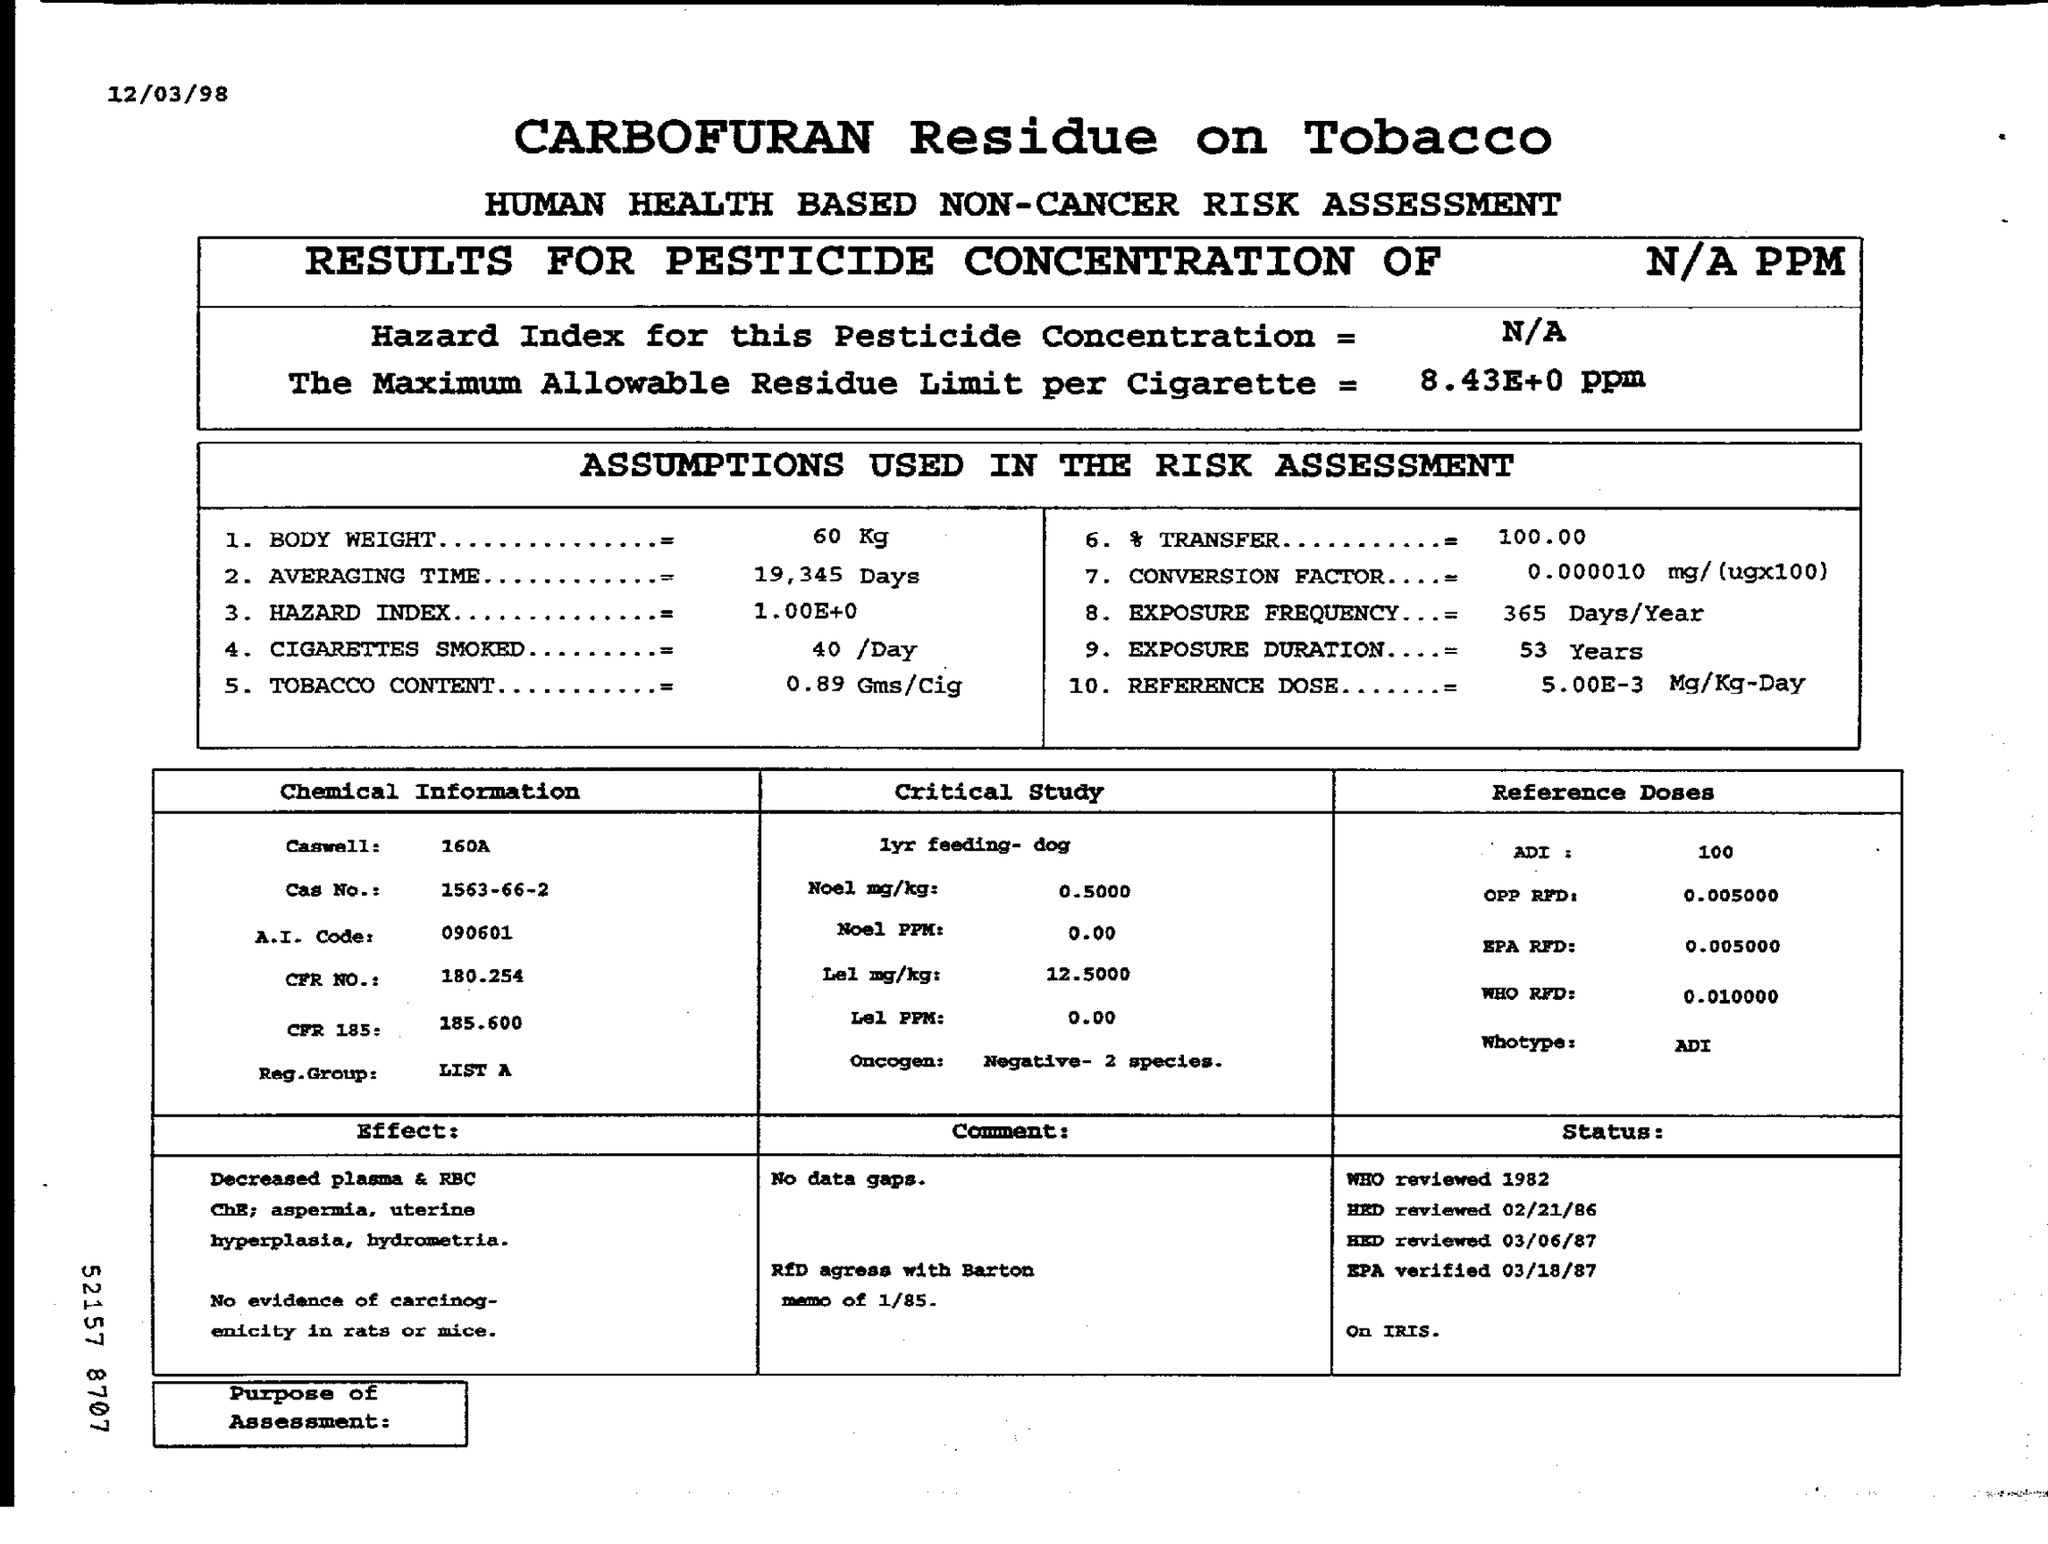What is the Title of the document?
Offer a terse response. Carbofuran residue on tobacco Human helath based non-cancer risk assessment. What is the Hazard Index for this Pesticide Concentration?
Provide a succinct answer. N/A. What is the Body weight?
Ensure brevity in your answer.  60 Kg. What is the Averaging Time?
Provide a short and direct response. 19,345 days. What is the Hazard Index?
Your answer should be compact. 1.00E+0. What is the Tobacco Content?
Make the answer very short. 0.89 Gms/Cig. What is the % Transfer?
Provide a short and direct response. 100.00. What is the Exposure Duration?
Make the answer very short. 53 Years. 